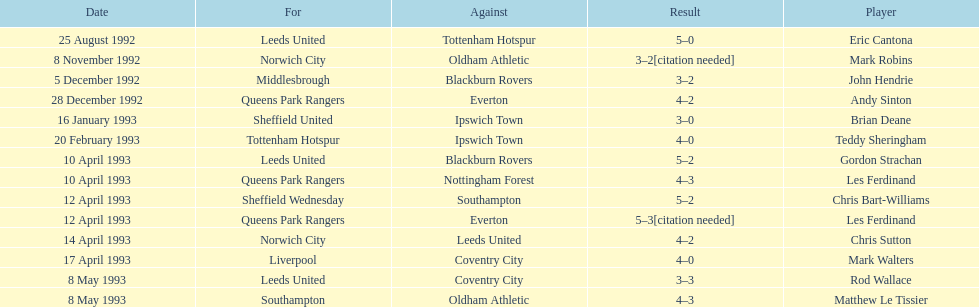Southampton played on may 8th, 1993, who was their opponent? Oldham Athletic. 